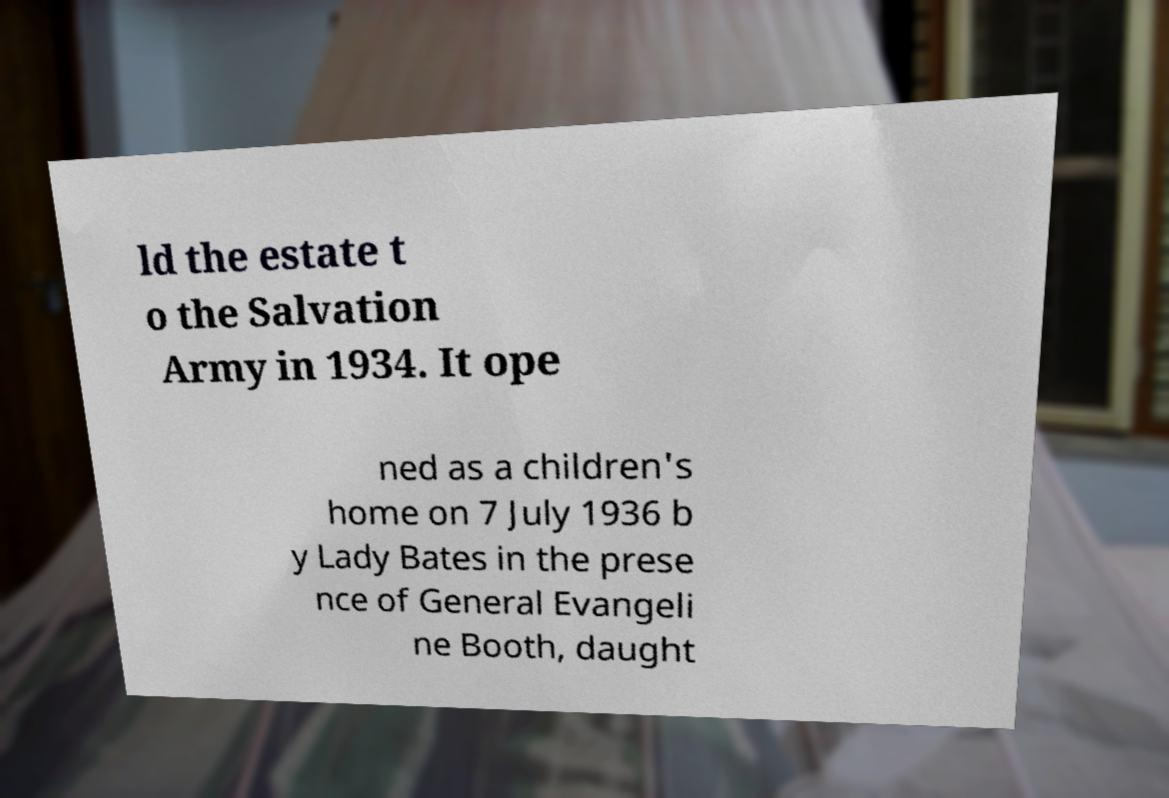Please identify and transcribe the text found in this image. ld the estate t o the Salvation Army in 1934. It ope ned as a children's home on 7 July 1936 b y Lady Bates in the prese nce of General Evangeli ne Booth, daught 